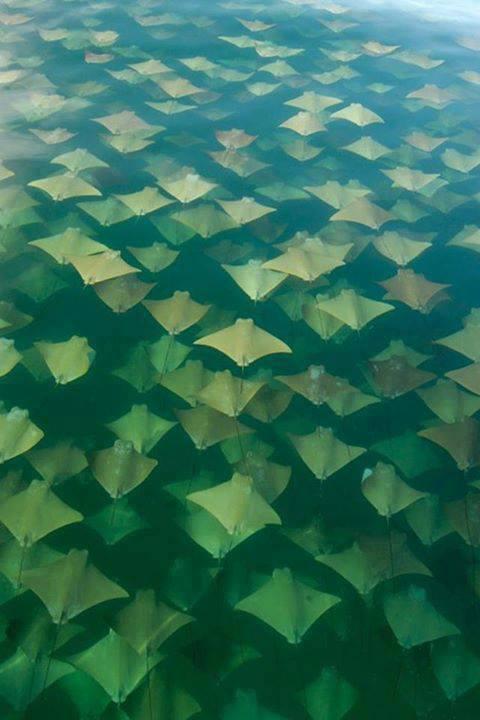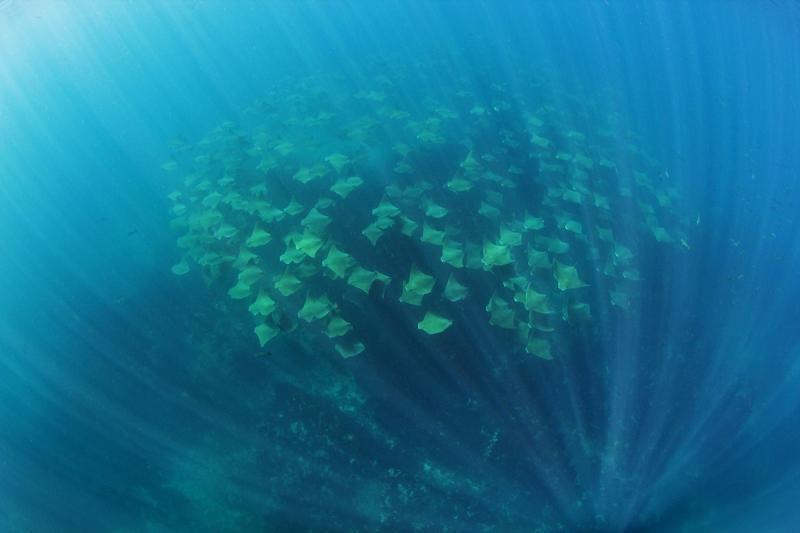The first image is the image on the left, the second image is the image on the right. For the images displayed, is the sentence "Animals are in blue water in the image on the right." factually correct? Answer yes or no. Yes. The first image is the image on the left, the second image is the image on the right. Given the left and right images, does the statement "An image shows a mass of stingrays in vivid blue water." hold true? Answer yes or no. Yes. 